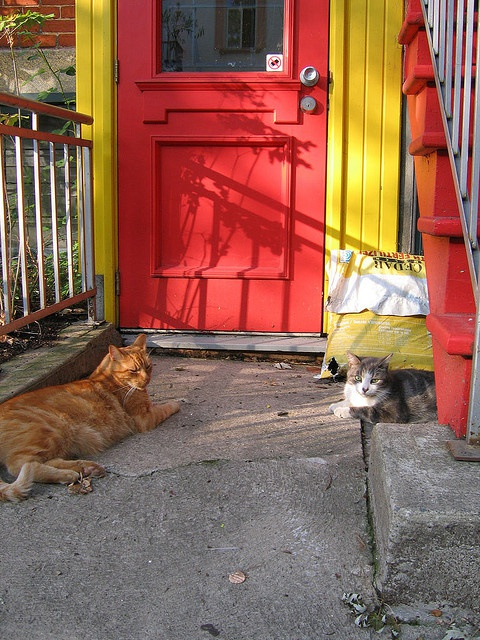Describe the objects in this image and their specific colors. I can see cat in maroon, gray, and brown tones and cat in maroon, gray, black, lightgray, and darkgray tones in this image. 